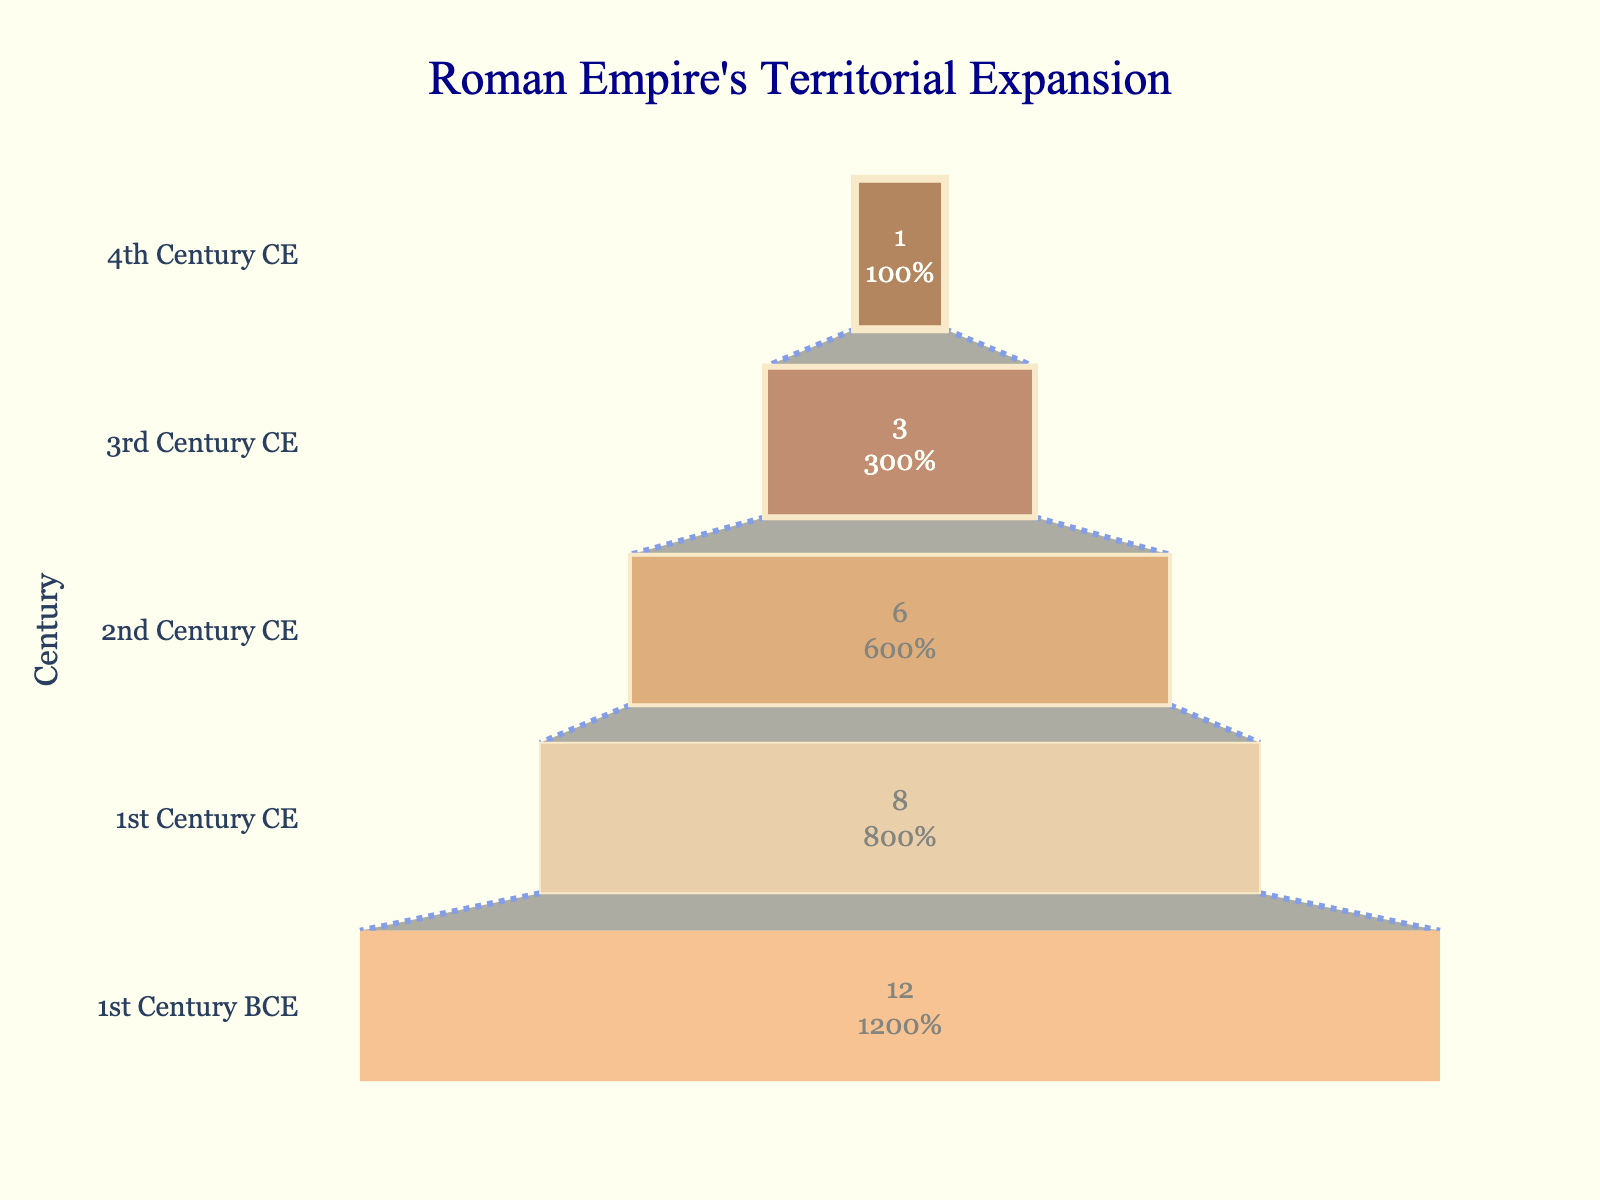What is the title of the chart? The title is at the top of the funnel chart and typically describes the content of the chart. In this case, the title reads "Roman Empire's Territorial Expansion".
Answer: Roman Empire's Territorial Expansion How many centuries are represented in the chart? The y-axis of the funnel chart lists different centuries. By counting these, you can identify that there are five.
Answer: Five In which century did the Roman Empire conquer the fewest regions? To answer this question, look for the smallest value in the chart. The 4th Century CE has the smallest bar, indicating the fewest conquered regions.
Answer: 4th Century CE How many regions were conquered in the 2nd Century CE? Refer to the value on the funnel chart corresponding to the 2nd Century CE. The segment representing this century has a value of 6.
Answer: 6 What is the color of the funnel segment representing the 1st Century BCE? The funnel chart uses different colors for each segment. The segment for the 1st Century BCE is colored in a shade of brown.
Answer: Brown What is the total number of conquered regions across all centuries? Add up the number of conquered regions for each century: 12 (1st Century BCE) + 8 (1st Century CE) + 6 (2nd Century CE) + 3 (3rd Century CE) + 1 (4th Century CE). The total is 30.
Answer: 30 Which century saw more territorial expansion: the 1st Century CE or the 3rd Century CE? Compare the sizes of the funnel segments for the two centuries. The 1st Century CE shows 8 conquered regions while the 3rd Century CE shows only 3. Therefore, the 1st Century CE saw more expansion.
Answer: 1st Century CE What percentage of the total conquests occurred in the 1st Century BCE? First, calculate the total number of conquered regions (30). The 1st Century BCE saw 12 conquests. To find the percentage, divide 12 by 30, then multiply by 100. The percentage is approximately 40%.
Answer: 40% How does the number of conquered regions in the 2nd Century CE compare to the 4th Century CE? Look at the values for both centuries on the chart. The 2nd Century CE has 6 conquered regions while the 4th Century CE has only 1. The 2nd Century CE has more.
Answer: 2nd Century CE During which century did the Roman Empire experience a drop in the number of conquered regions compared to the previous century? Identify the changes in the funnel segments between consecutive centuries. From the 1st Century CE (8 regions) to the 2nd Century CE (6 regions), there is a drop of 2 regions. Thus, the drop occurred in the 2nd Century CE compared to the 1st.
Answer: 2nd Century CE 